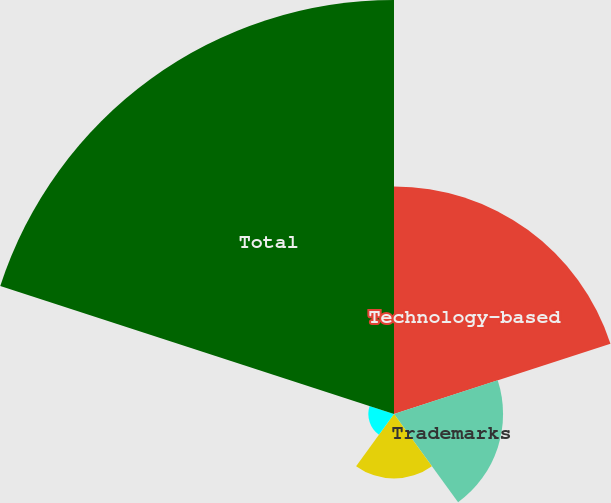Convert chart to OTSL. <chart><loc_0><loc_0><loc_500><loc_500><pie_chart><fcel>Technology-based<fcel>Trademarks<fcel>Contract-based<fcel>Customer relationships<fcel>Total<nl><fcel>27.07%<fcel>12.97%<fcel>7.67%<fcel>3.05%<fcel>49.24%<nl></chart> 